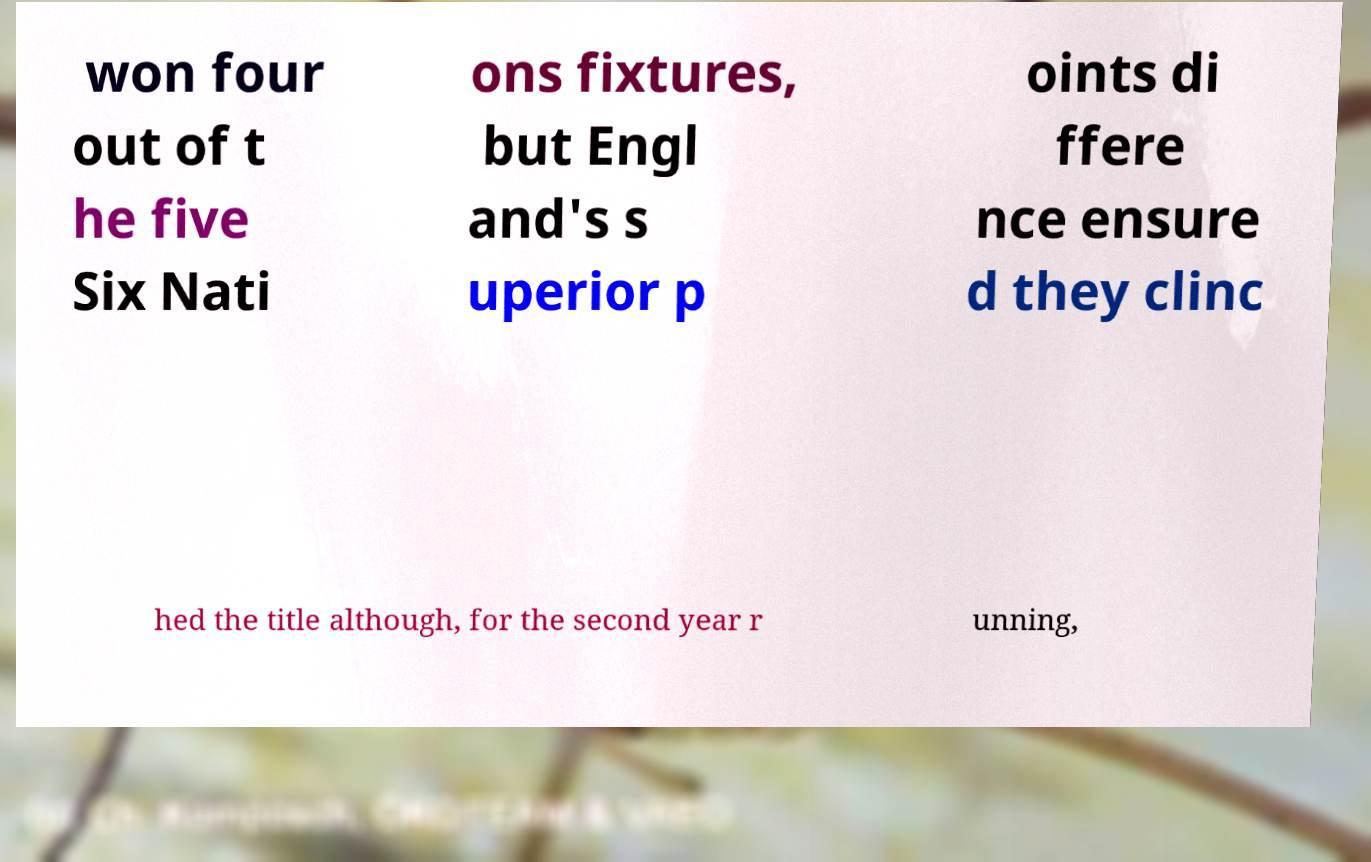Could you extract and type out the text from this image? won four out of t he five Six Nati ons fixtures, but Engl and's s uperior p oints di ffere nce ensure d they clinc hed the title although, for the second year r unning, 